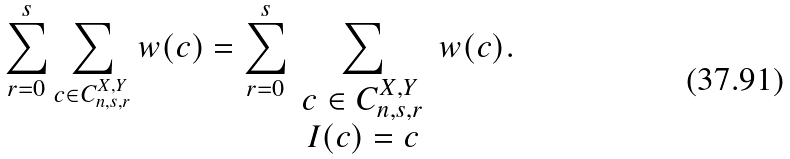Convert formula to latex. <formula><loc_0><loc_0><loc_500><loc_500>\sum _ { r = 0 } ^ { s } \sum _ { c \in C _ { n , s , r } ^ { X , Y } } w ( c ) = \sum _ { r = 0 } ^ { s } \sum _ { \begin{array} { c c } c \in C _ { n , s , r } ^ { X , Y } \\ I ( c ) = c \end{array} } w ( c ) .</formula> 